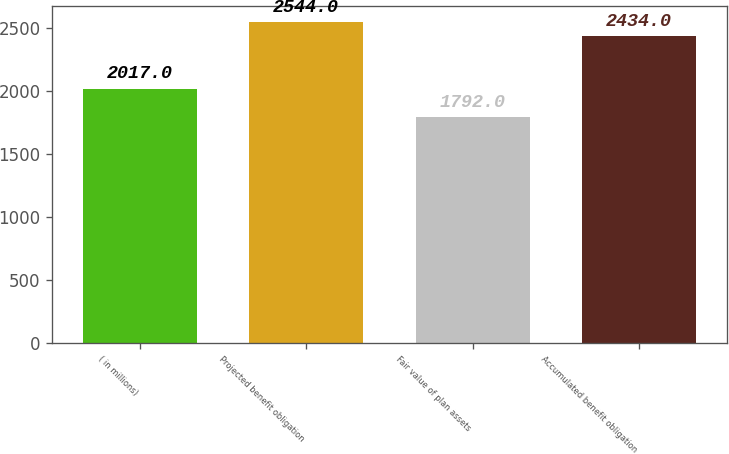Convert chart. <chart><loc_0><loc_0><loc_500><loc_500><bar_chart><fcel>( in millions)<fcel>Projected benefit obligation<fcel>Fair value of plan assets<fcel>Accumulated benefit obligation<nl><fcel>2017<fcel>2544<fcel>1792<fcel>2434<nl></chart> 